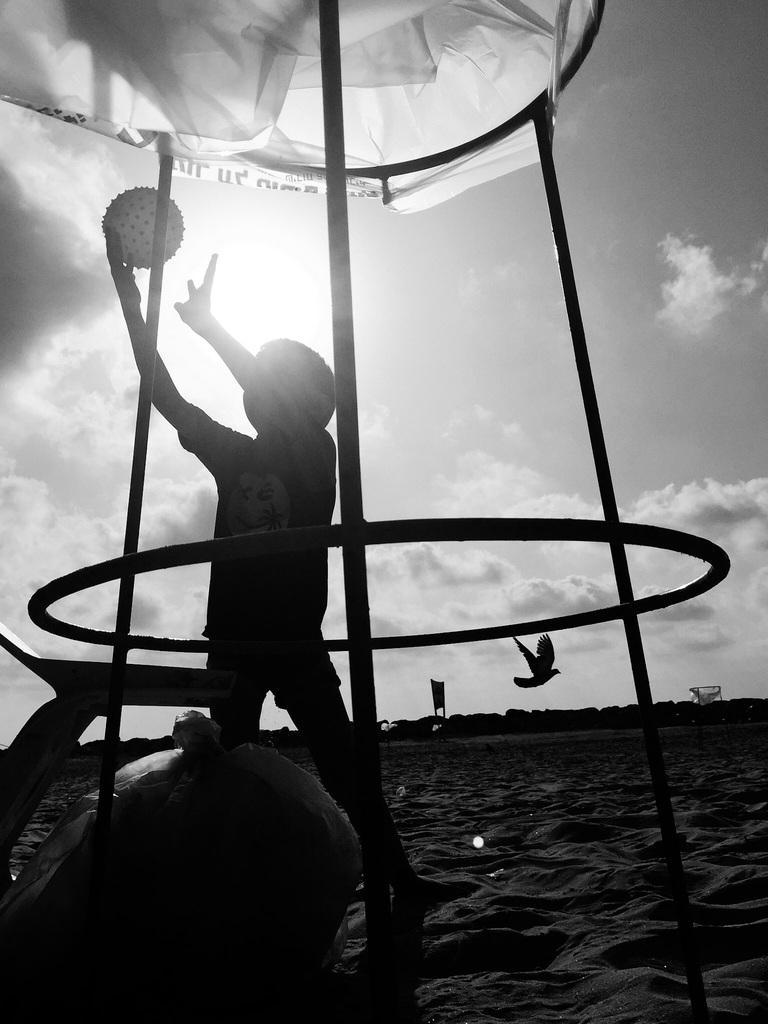Describe this image in one or two sentences. This picture is in black and white. The boy in the middle of the picture is playing with the ball. He is playing under the white color tint. At the bottom of the picture, we see sand. In the background, we see a board and the bird flying in the sky. At the top of the picture, we see the sky, clouds and the sun. 